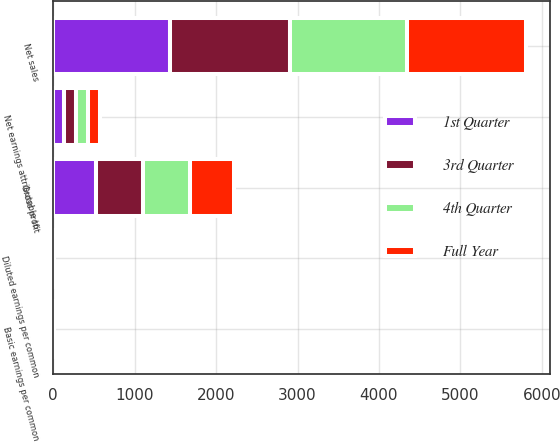Convert chart to OTSL. <chart><loc_0><loc_0><loc_500><loc_500><stacked_bar_chart><ecel><fcel>Net sales<fcel>Gross profit<fcel>Net earnings attributable to<fcel>Basic earnings per common<fcel>Diluted earnings per common<nl><fcel>4th Quarter<fcel>1440.9<fcel>572.2<fcel>147.2<fcel>1.58<fcel>1.56<nl><fcel>3rd Quarter<fcel>1468.2<fcel>577.3<fcel>151.9<fcel>1.65<fcel>1.62<nl><fcel>Full Year<fcel>1462.2<fcel>547.6<fcel>148.3<fcel>1.66<fcel>1.63<nl><fcel>1st Quarter<fcel>1437<fcel>526.1<fcel>126.4<fcel>1.46<fcel>1.43<nl></chart> 